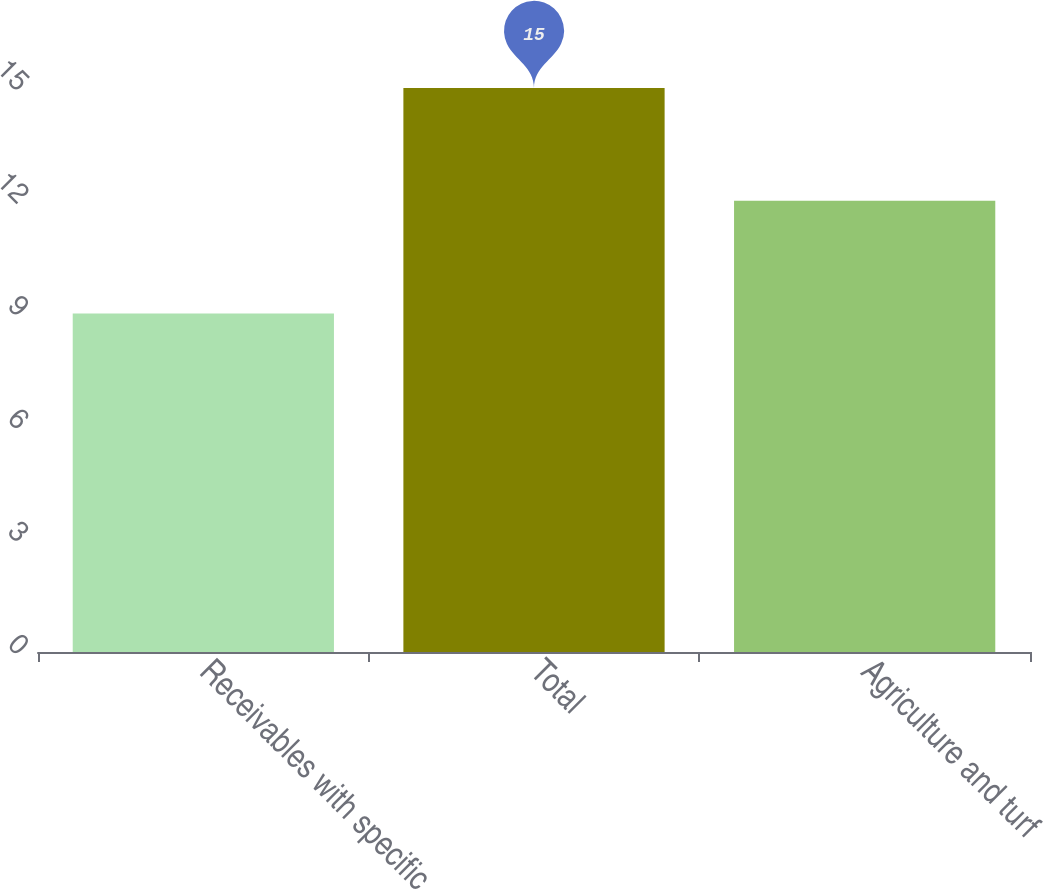Convert chart. <chart><loc_0><loc_0><loc_500><loc_500><bar_chart><fcel>Receivables with specific<fcel>Total<fcel>Agriculture and turf<nl><fcel>9<fcel>15<fcel>12<nl></chart> 